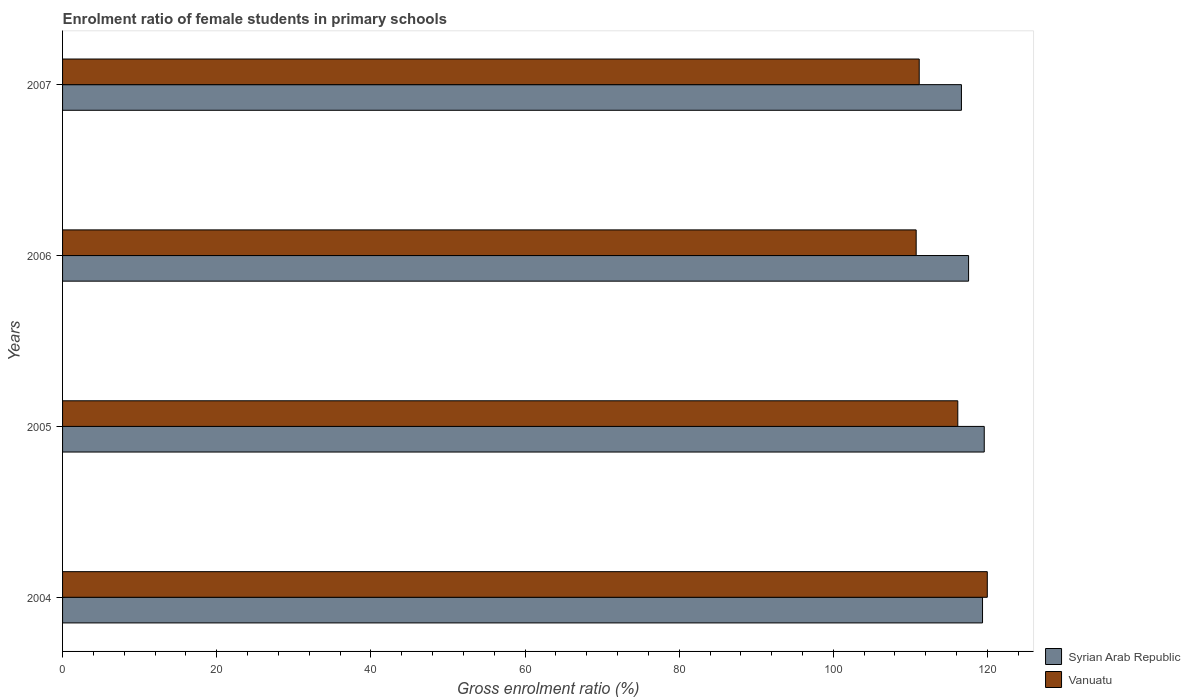How many different coloured bars are there?
Your answer should be very brief. 2. Are the number of bars per tick equal to the number of legend labels?
Make the answer very short. Yes. Are the number of bars on each tick of the Y-axis equal?
Your response must be concise. Yes. In how many cases, is the number of bars for a given year not equal to the number of legend labels?
Your answer should be compact. 0. What is the enrolment ratio of female students in primary schools in Syrian Arab Republic in 2005?
Offer a terse response. 119.58. Across all years, what is the maximum enrolment ratio of female students in primary schools in Syrian Arab Republic?
Ensure brevity in your answer.  119.58. Across all years, what is the minimum enrolment ratio of female students in primary schools in Vanuatu?
Keep it short and to the point. 110.75. In which year was the enrolment ratio of female students in primary schools in Vanuatu maximum?
Offer a terse response. 2004. What is the total enrolment ratio of female students in primary schools in Syrian Arab Republic in the graph?
Give a very brief answer. 473.11. What is the difference between the enrolment ratio of female students in primary schools in Vanuatu in 2005 and that in 2007?
Make the answer very short. 5. What is the difference between the enrolment ratio of female students in primary schools in Syrian Arab Republic in 2006 and the enrolment ratio of female students in primary schools in Vanuatu in 2007?
Provide a succinct answer. 6.4. What is the average enrolment ratio of female students in primary schools in Syrian Arab Republic per year?
Make the answer very short. 118.28. In the year 2005, what is the difference between the enrolment ratio of female students in primary schools in Syrian Arab Republic and enrolment ratio of female students in primary schools in Vanuatu?
Make the answer very short. 3.43. In how many years, is the enrolment ratio of female students in primary schools in Vanuatu greater than 40 %?
Make the answer very short. 4. What is the ratio of the enrolment ratio of female students in primary schools in Syrian Arab Republic in 2004 to that in 2005?
Provide a succinct answer. 1. Is the difference between the enrolment ratio of female students in primary schools in Syrian Arab Republic in 2004 and 2005 greater than the difference between the enrolment ratio of female students in primary schools in Vanuatu in 2004 and 2005?
Offer a terse response. No. What is the difference between the highest and the second highest enrolment ratio of female students in primary schools in Syrian Arab Republic?
Make the answer very short. 0.22. What is the difference between the highest and the lowest enrolment ratio of female students in primary schools in Syrian Arab Republic?
Your answer should be very brief. 2.96. Is the sum of the enrolment ratio of female students in primary schools in Syrian Arab Republic in 2004 and 2007 greater than the maximum enrolment ratio of female students in primary schools in Vanuatu across all years?
Provide a short and direct response. Yes. What does the 2nd bar from the top in 2006 represents?
Offer a very short reply. Syrian Arab Republic. What does the 2nd bar from the bottom in 2005 represents?
Provide a succinct answer. Vanuatu. How many bars are there?
Provide a succinct answer. 8. Are all the bars in the graph horizontal?
Give a very brief answer. Yes. How many years are there in the graph?
Keep it short and to the point. 4. Are the values on the major ticks of X-axis written in scientific E-notation?
Provide a short and direct response. No. Does the graph contain any zero values?
Give a very brief answer. No. How are the legend labels stacked?
Offer a very short reply. Vertical. What is the title of the graph?
Make the answer very short. Enrolment ratio of female students in primary schools. What is the label or title of the Y-axis?
Ensure brevity in your answer.  Years. What is the Gross enrolment ratio (%) in Syrian Arab Republic in 2004?
Provide a succinct answer. 119.36. What is the Gross enrolment ratio (%) of Vanuatu in 2004?
Keep it short and to the point. 119.98. What is the Gross enrolment ratio (%) in Syrian Arab Republic in 2005?
Provide a short and direct response. 119.58. What is the Gross enrolment ratio (%) in Vanuatu in 2005?
Offer a terse response. 116.15. What is the Gross enrolment ratio (%) in Syrian Arab Republic in 2006?
Ensure brevity in your answer.  117.55. What is the Gross enrolment ratio (%) in Vanuatu in 2006?
Ensure brevity in your answer.  110.75. What is the Gross enrolment ratio (%) of Syrian Arab Republic in 2007?
Your answer should be compact. 116.62. What is the Gross enrolment ratio (%) in Vanuatu in 2007?
Your response must be concise. 111.14. Across all years, what is the maximum Gross enrolment ratio (%) of Syrian Arab Republic?
Your response must be concise. 119.58. Across all years, what is the maximum Gross enrolment ratio (%) in Vanuatu?
Your response must be concise. 119.98. Across all years, what is the minimum Gross enrolment ratio (%) in Syrian Arab Republic?
Offer a terse response. 116.62. Across all years, what is the minimum Gross enrolment ratio (%) in Vanuatu?
Make the answer very short. 110.75. What is the total Gross enrolment ratio (%) of Syrian Arab Republic in the graph?
Offer a terse response. 473.11. What is the total Gross enrolment ratio (%) in Vanuatu in the graph?
Your answer should be compact. 458.02. What is the difference between the Gross enrolment ratio (%) in Syrian Arab Republic in 2004 and that in 2005?
Ensure brevity in your answer.  -0.22. What is the difference between the Gross enrolment ratio (%) of Vanuatu in 2004 and that in 2005?
Offer a terse response. 3.83. What is the difference between the Gross enrolment ratio (%) of Syrian Arab Republic in 2004 and that in 2006?
Offer a very short reply. 1.81. What is the difference between the Gross enrolment ratio (%) in Vanuatu in 2004 and that in 2006?
Provide a succinct answer. 9.23. What is the difference between the Gross enrolment ratio (%) in Syrian Arab Republic in 2004 and that in 2007?
Make the answer very short. 2.74. What is the difference between the Gross enrolment ratio (%) in Vanuatu in 2004 and that in 2007?
Your response must be concise. 8.83. What is the difference between the Gross enrolment ratio (%) of Syrian Arab Republic in 2005 and that in 2006?
Provide a short and direct response. 2.03. What is the difference between the Gross enrolment ratio (%) of Vanuatu in 2005 and that in 2006?
Your answer should be compact. 5.4. What is the difference between the Gross enrolment ratio (%) in Syrian Arab Republic in 2005 and that in 2007?
Keep it short and to the point. 2.96. What is the difference between the Gross enrolment ratio (%) in Vanuatu in 2005 and that in 2007?
Offer a very short reply. 5. What is the difference between the Gross enrolment ratio (%) of Syrian Arab Republic in 2006 and that in 2007?
Your answer should be very brief. 0.93. What is the difference between the Gross enrolment ratio (%) of Vanuatu in 2006 and that in 2007?
Your answer should be compact. -0.4. What is the difference between the Gross enrolment ratio (%) of Syrian Arab Republic in 2004 and the Gross enrolment ratio (%) of Vanuatu in 2005?
Provide a succinct answer. 3.21. What is the difference between the Gross enrolment ratio (%) in Syrian Arab Republic in 2004 and the Gross enrolment ratio (%) in Vanuatu in 2006?
Provide a short and direct response. 8.61. What is the difference between the Gross enrolment ratio (%) of Syrian Arab Republic in 2004 and the Gross enrolment ratio (%) of Vanuatu in 2007?
Offer a very short reply. 8.21. What is the difference between the Gross enrolment ratio (%) of Syrian Arab Republic in 2005 and the Gross enrolment ratio (%) of Vanuatu in 2006?
Your answer should be very brief. 8.83. What is the difference between the Gross enrolment ratio (%) of Syrian Arab Republic in 2005 and the Gross enrolment ratio (%) of Vanuatu in 2007?
Ensure brevity in your answer.  8.44. What is the difference between the Gross enrolment ratio (%) of Syrian Arab Republic in 2006 and the Gross enrolment ratio (%) of Vanuatu in 2007?
Give a very brief answer. 6.4. What is the average Gross enrolment ratio (%) in Syrian Arab Republic per year?
Make the answer very short. 118.28. What is the average Gross enrolment ratio (%) of Vanuatu per year?
Provide a short and direct response. 114.51. In the year 2004, what is the difference between the Gross enrolment ratio (%) of Syrian Arab Republic and Gross enrolment ratio (%) of Vanuatu?
Your answer should be very brief. -0.62. In the year 2005, what is the difference between the Gross enrolment ratio (%) in Syrian Arab Republic and Gross enrolment ratio (%) in Vanuatu?
Ensure brevity in your answer.  3.43. In the year 2006, what is the difference between the Gross enrolment ratio (%) in Syrian Arab Republic and Gross enrolment ratio (%) in Vanuatu?
Provide a short and direct response. 6.8. In the year 2007, what is the difference between the Gross enrolment ratio (%) in Syrian Arab Republic and Gross enrolment ratio (%) in Vanuatu?
Keep it short and to the point. 5.48. What is the ratio of the Gross enrolment ratio (%) of Vanuatu in 2004 to that in 2005?
Ensure brevity in your answer.  1.03. What is the ratio of the Gross enrolment ratio (%) in Syrian Arab Republic in 2004 to that in 2006?
Provide a succinct answer. 1.02. What is the ratio of the Gross enrolment ratio (%) in Vanuatu in 2004 to that in 2006?
Offer a terse response. 1.08. What is the ratio of the Gross enrolment ratio (%) in Syrian Arab Republic in 2004 to that in 2007?
Provide a short and direct response. 1.02. What is the ratio of the Gross enrolment ratio (%) in Vanuatu in 2004 to that in 2007?
Offer a very short reply. 1.08. What is the ratio of the Gross enrolment ratio (%) in Syrian Arab Republic in 2005 to that in 2006?
Offer a very short reply. 1.02. What is the ratio of the Gross enrolment ratio (%) of Vanuatu in 2005 to that in 2006?
Keep it short and to the point. 1.05. What is the ratio of the Gross enrolment ratio (%) of Syrian Arab Republic in 2005 to that in 2007?
Ensure brevity in your answer.  1.03. What is the ratio of the Gross enrolment ratio (%) of Vanuatu in 2005 to that in 2007?
Provide a succinct answer. 1.04. What is the ratio of the Gross enrolment ratio (%) of Syrian Arab Republic in 2006 to that in 2007?
Give a very brief answer. 1.01. What is the difference between the highest and the second highest Gross enrolment ratio (%) in Syrian Arab Republic?
Offer a terse response. 0.22. What is the difference between the highest and the second highest Gross enrolment ratio (%) in Vanuatu?
Your answer should be compact. 3.83. What is the difference between the highest and the lowest Gross enrolment ratio (%) in Syrian Arab Republic?
Provide a short and direct response. 2.96. What is the difference between the highest and the lowest Gross enrolment ratio (%) of Vanuatu?
Your answer should be very brief. 9.23. 